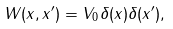<formula> <loc_0><loc_0><loc_500><loc_500>W ( x , x ^ { \prime } ) = V _ { 0 } \delta ( x ) \delta ( x ^ { \prime } ) ,</formula> 